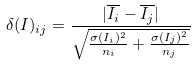Convert formula to latex. <formula><loc_0><loc_0><loc_500><loc_500>\delta ( I ) _ { i j } = \frac { | \overline { I _ { i } } - \overline { I _ { j } } | } { \sqrt { \frac { \sigma ( I _ { i } ) ^ { 2 } } { n _ { i } } + \frac { \sigma ( I _ { j } ) ^ { 2 } } { n _ { j } } } }</formula> 